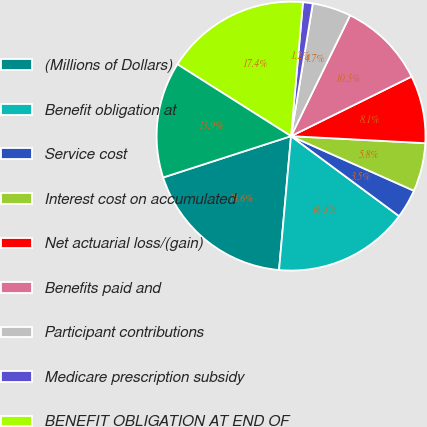Convert chart to OTSL. <chart><loc_0><loc_0><loc_500><loc_500><pie_chart><fcel>(Millions of Dollars)<fcel>Benefit obligation at<fcel>Service cost<fcel>Interest cost on accumulated<fcel>Net actuarial loss/(gain)<fcel>Benefits paid and<fcel>Participant contributions<fcel>Medicare prescription subsidy<fcel>BENEFIT OBLIGATION AT END OF<fcel>Fair value of plan assets at<nl><fcel>18.6%<fcel>16.28%<fcel>3.49%<fcel>5.82%<fcel>8.14%<fcel>10.46%<fcel>4.65%<fcel>1.17%<fcel>17.44%<fcel>13.95%<nl></chart> 